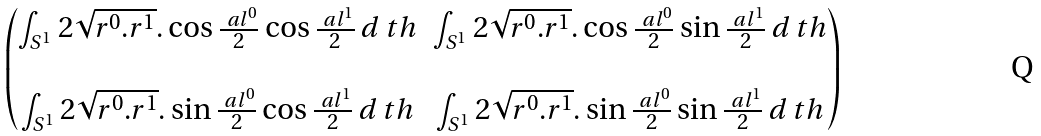Convert formula to latex. <formula><loc_0><loc_0><loc_500><loc_500>\begin{pmatrix} \int _ { S ^ { 1 } } 2 \sqrt { r ^ { 0 } . r ^ { 1 } } . \cos \frac { \ a l ^ { 0 } } 2 \cos \frac { \ a l ^ { 1 } } 2 \, d \ t h & \int _ { S ^ { 1 } } 2 \sqrt { r ^ { 0 } . r ^ { 1 } } . \cos \frac { \ a l ^ { 0 } } 2 \sin \frac { \ a l ^ { 1 } } 2 \, d \ t h \\ \\ \int _ { S ^ { 1 } } 2 \sqrt { r ^ { 0 } . r ^ { 1 } } . \sin \frac { \ a l ^ { 0 } } 2 \cos \frac { \ a l ^ { 1 } } 2 \, d \ t h & \int _ { S ^ { 1 } } 2 \sqrt { r ^ { 0 } . r ^ { 1 } } . \sin \frac { \ a l ^ { 0 } } 2 \sin \frac { \ a l ^ { 1 } } 2 \, d \ t h \end{pmatrix}</formula> 